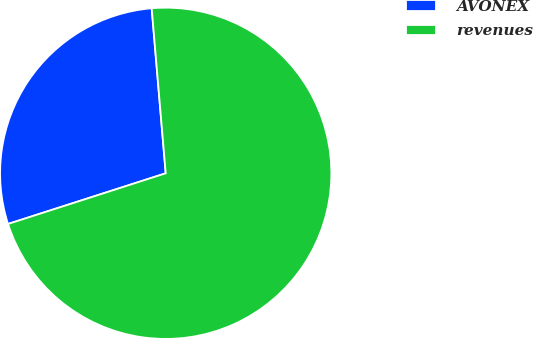Convert chart to OTSL. <chart><loc_0><loc_0><loc_500><loc_500><pie_chart><fcel>AVONEX<fcel>revenues<nl><fcel>28.6%<fcel>71.4%<nl></chart> 